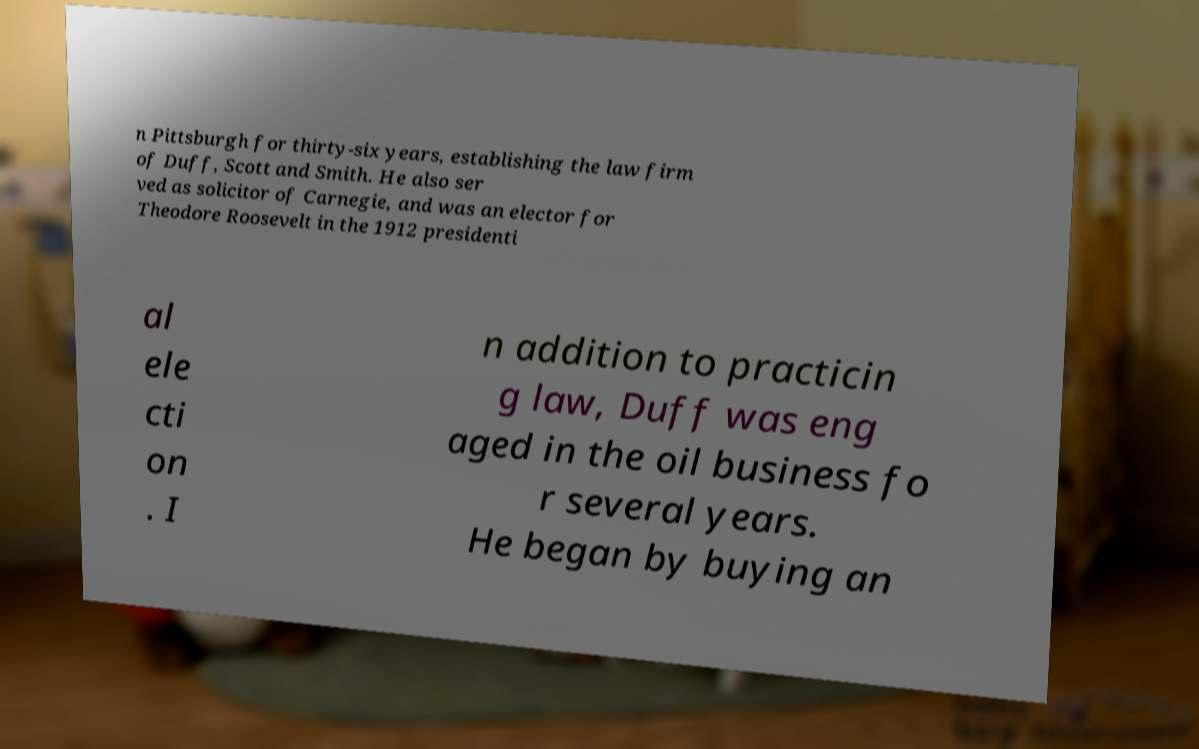I need the written content from this picture converted into text. Can you do that? n Pittsburgh for thirty-six years, establishing the law firm of Duff, Scott and Smith. He also ser ved as solicitor of Carnegie, and was an elector for Theodore Roosevelt in the 1912 presidenti al ele cti on . I n addition to practicin g law, Duff was eng aged in the oil business fo r several years. He began by buying an 